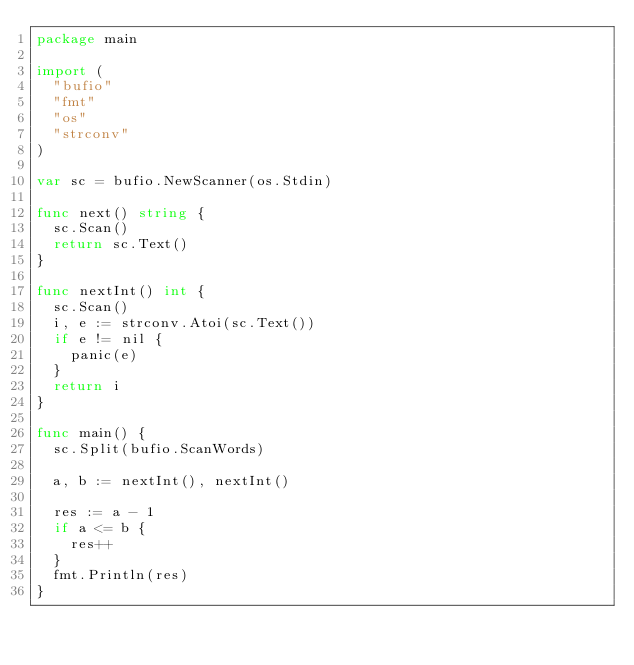Convert code to text. <code><loc_0><loc_0><loc_500><loc_500><_Go_>package main

import (
	"bufio"
	"fmt"
	"os"
	"strconv"
)

var sc = bufio.NewScanner(os.Stdin)

func next() string {
	sc.Scan()
	return sc.Text()
}

func nextInt() int {
	sc.Scan()
	i, e := strconv.Atoi(sc.Text())
	if e != nil {
		panic(e)
	}
	return i
}

func main() {
	sc.Split(bufio.ScanWords)

	a, b := nextInt(), nextInt()

	res := a - 1
	if a <= b {
		res++
	}
	fmt.Println(res)
}
</code> 